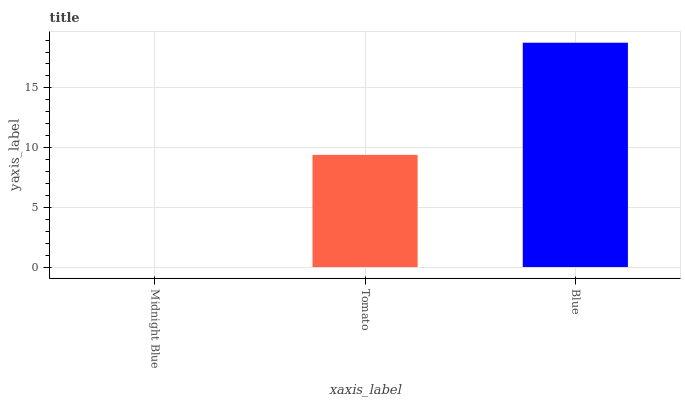Is Tomato the minimum?
Answer yes or no. No. Is Tomato the maximum?
Answer yes or no. No. Is Tomato greater than Midnight Blue?
Answer yes or no. Yes. Is Midnight Blue less than Tomato?
Answer yes or no. Yes. Is Midnight Blue greater than Tomato?
Answer yes or no. No. Is Tomato less than Midnight Blue?
Answer yes or no. No. Is Tomato the high median?
Answer yes or no. Yes. Is Tomato the low median?
Answer yes or no. Yes. Is Blue the high median?
Answer yes or no. No. Is Blue the low median?
Answer yes or no. No. 